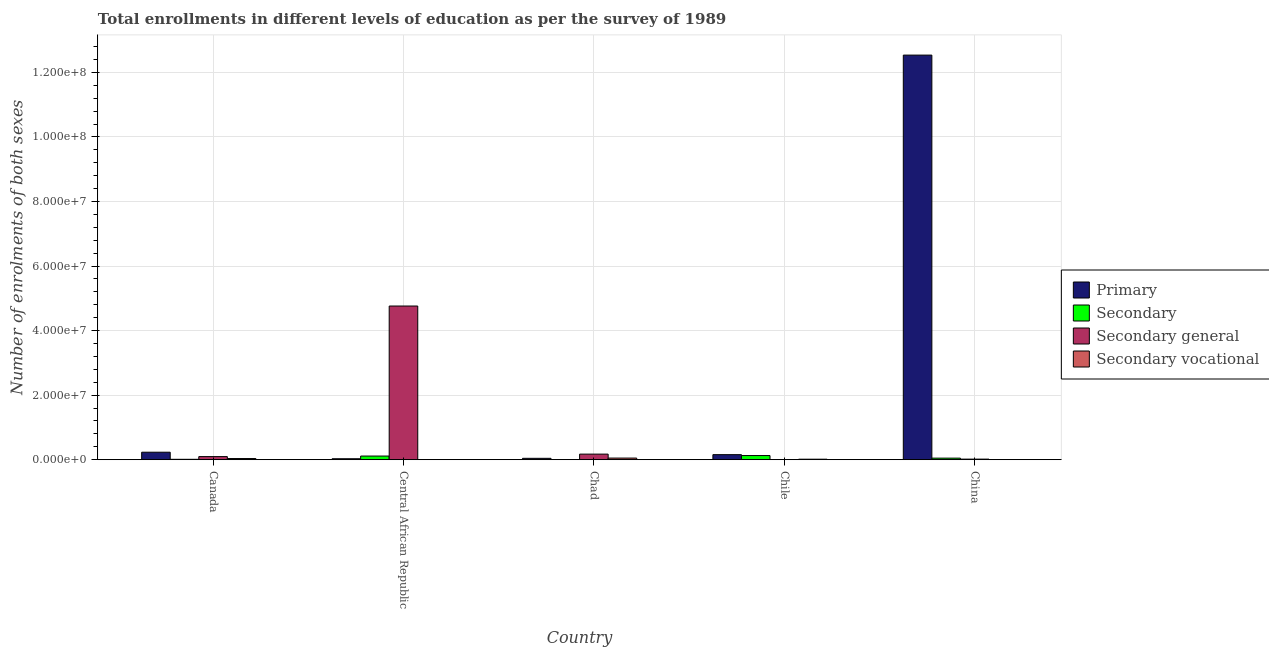How many different coloured bars are there?
Your answer should be compact. 4. Are the number of bars on each tick of the X-axis equal?
Offer a terse response. Yes. How many bars are there on the 2nd tick from the right?
Make the answer very short. 4. What is the number of enrolments in primary education in China?
Provide a short and direct response. 1.25e+08. Across all countries, what is the maximum number of enrolments in secondary general education?
Give a very brief answer. 4.76e+07. Across all countries, what is the minimum number of enrolments in secondary education?
Ensure brevity in your answer.  4.26e+04. In which country was the number of enrolments in primary education minimum?
Keep it short and to the point. Central African Republic. What is the total number of enrolments in secondary general education in the graph?
Your answer should be very brief. 5.05e+07. What is the difference between the number of enrolments in secondary education in Chad and that in Chile?
Keep it short and to the point. -1.24e+06. What is the difference between the number of enrolments in secondary education in Chad and the number of enrolments in primary education in Canada?
Your response must be concise. -2.28e+06. What is the average number of enrolments in secondary general education per country?
Give a very brief answer. 1.01e+07. What is the difference between the number of enrolments in secondary vocational education and number of enrolments in secondary general education in Chile?
Keep it short and to the point. 1.38e+05. What is the ratio of the number of enrolments in secondary vocational education in Canada to that in China?
Ensure brevity in your answer.  151.02. Is the difference between the number of enrolments in primary education in Canada and Chad greater than the difference between the number of enrolments in secondary general education in Canada and Chad?
Make the answer very short. Yes. What is the difference between the highest and the second highest number of enrolments in secondary general education?
Make the answer very short. 4.59e+07. What is the difference between the highest and the lowest number of enrolments in secondary general education?
Make the answer very short. 4.76e+07. Is the sum of the number of enrolments in secondary vocational education in Canada and China greater than the maximum number of enrolments in secondary education across all countries?
Offer a terse response. No. What does the 3rd bar from the left in Chile represents?
Your answer should be compact. Secondary general. What does the 4th bar from the right in China represents?
Your response must be concise. Primary. How many bars are there?
Provide a succinct answer. 20. Are all the bars in the graph horizontal?
Ensure brevity in your answer.  No. Does the graph contain any zero values?
Keep it short and to the point. No. Where does the legend appear in the graph?
Ensure brevity in your answer.  Center right. How are the legend labels stacked?
Offer a terse response. Vertical. What is the title of the graph?
Provide a short and direct response. Total enrollments in different levels of education as per the survey of 1989. What is the label or title of the X-axis?
Your answer should be compact. Country. What is the label or title of the Y-axis?
Your answer should be compact. Number of enrolments of both sexes. What is the Number of enrolments of both sexes of Primary in Canada?
Your response must be concise. 2.32e+06. What is the Number of enrolments of both sexes of Secondary in Canada?
Give a very brief answer. 1.23e+05. What is the Number of enrolments of both sexes in Secondary general in Canada?
Offer a terse response. 9.62e+05. What is the Number of enrolments of both sexes in Secondary vocational in Canada?
Your answer should be very brief. 3.57e+05. What is the Number of enrolments of both sexes of Primary in Central African Republic?
Provide a short and direct response. 2.97e+05. What is the Number of enrolments of both sexes in Secondary in Central African Republic?
Your answer should be compact. 1.13e+06. What is the Number of enrolments of both sexes in Secondary general in Central African Republic?
Make the answer very short. 4.76e+07. What is the Number of enrolments of both sexes of Secondary vocational in Central African Republic?
Make the answer very short. 3314. What is the Number of enrolments of both sexes in Primary in Chad?
Your answer should be compact. 4.25e+05. What is the Number of enrolments of both sexes in Secondary in Chad?
Give a very brief answer. 4.26e+04. What is the Number of enrolments of both sexes of Secondary general in Chad?
Your answer should be very brief. 1.73e+06. What is the Number of enrolments of both sexes in Secondary vocational in Chad?
Ensure brevity in your answer.  5.05e+05. What is the Number of enrolments of both sexes of Primary in Chile?
Your answer should be very brief. 1.56e+06. What is the Number of enrolments of both sexes of Secondary in Chile?
Give a very brief answer. 1.29e+06. What is the Number of enrolments of both sexes in Secondary general in Chile?
Offer a very short reply. 1.73e+04. What is the Number of enrolments of both sexes in Secondary vocational in Chile?
Ensure brevity in your answer.  1.56e+05. What is the Number of enrolments of both sexes of Primary in China?
Provide a short and direct response. 1.25e+08. What is the Number of enrolments of both sexes in Secondary in China?
Offer a very short reply. 4.84e+05. What is the Number of enrolments of both sexes in Secondary general in China?
Your answer should be very brief. 1.80e+05. What is the Number of enrolments of both sexes in Secondary vocational in China?
Make the answer very short. 2366. Across all countries, what is the maximum Number of enrolments of both sexes in Primary?
Your response must be concise. 1.25e+08. Across all countries, what is the maximum Number of enrolments of both sexes in Secondary?
Offer a very short reply. 1.29e+06. Across all countries, what is the maximum Number of enrolments of both sexes in Secondary general?
Provide a succinct answer. 4.76e+07. Across all countries, what is the maximum Number of enrolments of both sexes in Secondary vocational?
Give a very brief answer. 5.05e+05. Across all countries, what is the minimum Number of enrolments of both sexes in Primary?
Provide a short and direct response. 2.97e+05. Across all countries, what is the minimum Number of enrolments of both sexes in Secondary?
Make the answer very short. 4.26e+04. Across all countries, what is the minimum Number of enrolments of both sexes of Secondary general?
Your answer should be compact. 1.73e+04. Across all countries, what is the minimum Number of enrolments of both sexes in Secondary vocational?
Your answer should be very brief. 2366. What is the total Number of enrolments of both sexes of Primary in the graph?
Give a very brief answer. 1.30e+08. What is the total Number of enrolments of both sexes of Secondary in the graph?
Your response must be concise. 3.06e+06. What is the total Number of enrolments of both sexes of Secondary general in the graph?
Provide a short and direct response. 5.05e+07. What is the total Number of enrolments of both sexes of Secondary vocational in the graph?
Keep it short and to the point. 1.02e+06. What is the difference between the Number of enrolments of both sexes in Primary in Canada and that in Central African Republic?
Give a very brief answer. 2.02e+06. What is the difference between the Number of enrolments of both sexes in Secondary in Canada and that in Central African Republic?
Make the answer very short. -1.00e+06. What is the difference between the Number of enrolments of both sexes of Secondary general in Canada and that in Central African Republic?
Your answer should be very brief. -4.67e+07. What is the difference between the Number of enrolments of both sexes of Secondary vocational in Canada and that in Central African Republic?
Give a very brief answer. 3.54e+05. What is the difference between the Number of enrolments of both sexes of Primary in Canada and that in Chad?
Keep it short and to the point. 1.89e+06. What is the difference between the Number of enrolments of both sexes of Secondary in Canada and that in Chad?
Your response must be concise. 8.04e+04. What is the difference between the Number of enrolments of both sexes in Secondary general in Canada and that in Chad?
Your answer should be compact. -7.67e+05. What is the difference between the Number of enrolments of both sexes in Secondary vocational in Canada and that in Chad?
Offer a very short reply. -1.48e+05. What is the difference between the Number of enrolments of both sexes of Primary in Canada and that in Chile?
Your answer should be compact. 7.55e+05. What is the difference between the Number of enrolments of both sexes of Secondary in Canada and that in Chile?
Give a very brief answer. -1.16e+06. What is the difference between the Number of enrolments of both sexes of Secondary general in Canada and that in Chile?
Keep it short and to the point. 9.44e+05. What is the difference between the Number of enrolments of both sexes in Secondary vocational in Canada and that in Chile?
Ensure brevity in your answer.  2.02e+05. What is the difference between the Number of enrolments of both sexes of Primary in Canada and that in China?
Provide a succinct answer. -1.23e+08. What is the difference between the Number of enrolments of both sexes of Secondary in Canada and that in China?
Provide a short and direct response. -3.60e+05. What is the difference between the Number of enrolments of both sexes in Secondary general in Canada and that in China?
Ensure brevity in your answer.  7.82e+05. What is the difference between the Number of enrolments of both sexes of Secondary vocational in Canada and that in China?
Make the answer very short. 3.55e+05. What is the difference between the Number of enrolments of both sexes in Primary in Central African Republic and that in Chad?
Provide a succinct answer. -1.27e+05. What is the difference between the Number of enrolments of both sexes of Secondary in Central African Republic and that in Chad?
Your answer should be compact. 1.08e+06. What is the difference between the Number of enrolments of both sexes in Secondary general in Central African Republic and that in Chad?
Your response must be concise. 4.59e+07. What is the difference between the Number of enrolments of both sexes of Secondary vocational in Central African Republic and that in Chad?
Provide a short and direct response. -5.02e+05. What is the difference between the Number of enrolments of both sexes of Primary in Central African Republic and that in Chile?
Keep it short and to the point. -1.27e+06. What is the difference between the Number of enrolments of both sexes of Secondary in Central African Republic and that in Chile?
Your response must be concise. -1.59e+05. What is the difference between the Number of enrolments of both sexes of Secondary general in Central African Republic and that in Chile?
Your answer should be compact. 4.76e+07. What is the difference between the Number of enrolments of both sexes in Secondary vocational in Central African Republic and that in Chile?
Make the answer very short. -1.52e+05. What is the difference between the Number of enrolments of both sexes of Primary in Central African Republic and that in China?
Offer a very short reply. -1.25e+08. What is the difference between the Number of enrolments of both sexes in Secondary in Central African Republic and that in China?
Ensure brevity in your answer.  6.44e+05. What is the difference between the Number of enrolments of both sexes in Secondary general in Central African Republic and that in China?
Provide a succinct answer. 4.74e+07. What is the difference between the Number of enrolments of both sexes in Secondary vocational in Central African Republic and that in China?
Make the answer very short. 948. What is the difference between the Number of enrolments of both sexes in Primary in Chad and that in Chile?
Provide a succinct answer. -1.14e+06. What is the difference between the Number of enrolments of both sexes in Secondary in Chad and that in Chile?
Offer a very short reply. -1.24e+06. What is the difference between the Number of enrolments of both sexes of Secondary general in Chad and that in Chile?
Provide a short and direct response. 1.71e+06. What is the difference between the Number of enrolments of both sexes in Secondary vocational in Chad and that in Chile?
Make the answer very short. 3.50e+05. What is the difference between the Number of enrolments of both sexes of Primary in Chad and that in China?
Ensure brevity in your answer.  -1.25e+08. What is the difference between the Number of enrolments of both sexes in Secondary in Chad and that in China?
Your response must be concise. -4.41e+05. What is the difference between the Number of enrolments of both sexes in Secondary general in Chad and that in China?
Offer a terse response. 1.55e+06. What is the difference between the Number of enrolments of both sexes of Secondary vocational in Chad and that in China?
Your response must be concise. 5.03e+05. What is the difference between the Number of enrolments of both sexes in Primary in Chile and that in China?
Your answer should be compact. -1.24e+08. What is the difference between the Number of enrolments of both sexes in Secondary in Chile and that in China?
Offer a very short reply. 8.02e+05. What is the difference between the Number of enrolments of both sexes of Secondary general in Chile and that in China?
Provide a succinct answer. -1.63e+05. What is the difference between the Number of enrolments of both sexes in Secondary vocational in Chile and that in China?
Offer a very short reply. 1.53e+05. What is the difference between the Number of enrolments of both sexes in Primary in Canada and the Number of enrolments of both sexes in Secondary in Central African Republic?
Offer a very short reply. 1.19e+06. What is the difference between the Number of enrolments of both sexes of Primary in Canada and the Number of enrolments of both sexes of Secondary general in Central African Republic?
Make the answer very short. -4.53e+07. What is the difference between the Number of enrolments of both sexes in Primary in Canada and the Number of enrolments of both sexes in Secondary vocational in Central African Republic?
Keep it short and to the point. 2.32e+06. What is the difference between the Number of enrolments of both sexes in Secondary in Canada and the Number of enrolments of both sexes in Secondary general in Central African Republic?
Your answer should be compact. -4.75e+07. What is the difference between the Number of enrolments of both sexes of Secondary in Canada and the Number of enrolments of both sexes of Secondary vocational in Central African Republic?
Your answer should be very brief. 1.20e+05. What is the difference between the Number of enrolments of both sexes of Secondary general in Canada and the Number of enrolments of both sexes of Secondary vocational in Central African Republic?
Offer a very short reply. 9.58e+05. What is the difference between the Number of enrolments of both sexes in Primary in Canada and the Number of enrolments of both sexes in Secondary in Chad?
Provide a succinct answer. 2.28e+06. What is the difference between the Number of enrolments of both sexes in Primary in Canada and the Number of enrolments of both sexes in Secondary general in Chad?
Provide a succinct answer. 5.90e+05. What is the difference between the Number of enrolments of both sexes of Primary in Canada and the Number of enrolments of both sexes of Secondary vocational in Chad?
Offer a terse response. 1.81e+06. What is the difference between the Number of enrolments of both sexes of Secondary in Canada and the Number of enrolments of both sexes of Secondary general in Chad?
Keep it short and to the point. -1.61e+06. What is the difference between the Number of enrolments of both sexes of Secondary in Canada and the Number of enrolments of both sexes of Secondary vocational in Chad?
Your response must be concise. -3.82e+05. What is the difference between the Number of enrolments of both sexes in Secondary general in Canada and the Number of enrolments of both sexes in Secondary vocational in Chad?
Offer a very short reply. 4.56e+05. What is the difference between the Number of enrolments of both sexes of Primary in Canada and the Number of enrolments of both sexes of Secondary in Chile?
Your response must be concise. 1.03e+06. What is the difference between the Number of enrolments of both sexes in Primary in Canada and the Number of enrolments of both sexes in Secondary general in Chile?
Make the answer very short. 2.30e+06. What is the difference between the Number of enrolments of both sexes of Primary in Canada and the Number of enrolments of both sexes of Secondary vocational in Chile?
Your answer should be compact. 2.16e+06. What is the difference between the Number of enrolments of both sexes of Secondary in Canada and the Number of enrolments of both sexes of Secondary general in Chile?
Provide a short and direct response. 1.06e+05. What is the difference between the Number of enrolments of both sexes of Secondary in Canada and the Number of enrolments of both sexes of Secondary vocational in Chile?
Provide a short and direct response. -3.27e+04. What is the difference between the Number of enrolments of both sexes of Secondary general in Canada and the Number of enrolments of both sexes of Secondary vocational in Chile?
Provide a succinct answer. 8.06e+05. What is the difference between the Number of enrolments of both sexes in Primary in Canada and the Number of enrolments of both sexes in Secondary in China?
Ensure brevity in your answer.  1.84e+06. What is the difference between the Number of enrolments of both sexes of Primary in Canada and the Number of enrolments of both sexes of Secondary general in China?
Offer a very short reply. 2.14e+06. What is the difference between the Number of enrolments of both sexes of Primary in Canada and the Number of enrolments of both sexes of Secondary vocational in China?
Make the answer very short. 2.32e+06. What is the difference between the Number of enrolments of both sexes in Secondary in Canada and the Number of enrolments of both sexes in Secondary general in China?
Offer a terse response. -5.68e+04. What is the difference between the Number of enrolments of both sexes of Secondary in Canada and the Number of enrolments of both sexes of Secondary vocational in China?
Your answer should be very brief. 1.21e+05. What is the difference between the Number of enrolments of both sexes in Secondary general in Canada and the Number of enrolments of both sexes in Secondary vocational in China?
Give a very brief answer. 9.59e+05. What is the difference between the Number of enrolments of both sexes of Primary in Central African Republic and the Number of enrolments of both sexes of Secondary in Chad?
Your answer should be very brief. 2.55e+05. What is the difference between the Number of enrolments of both sexes in Primary in Central African Republic and the Number of enrolments of both sexes in Secondary general in Chad?
Offer a very short reply. -1.43e+06. What is the difference between the Number of enrolments of both sexes of Primary in Central African Republic and the Number of enrolments of both sexes of Secondary vocational in Chad?
Provide a succinct answer. -2.08e+05. What is the difference between the Number of enrolments of both sexes of Secondary in Central African Republic and the Number of enrolments of both sexes of Secondary general in Chad?
Make the answer very short. -6.02e+05. What is the difference between the Number of enrolments of both sexes in Secondary in Central African Republic and the Number of enrolments of both sexes in Secondary vocational in Chad?
Offer a terse response. 6.22e+05. What is the difference between the Number of enrolments of both sexes in Secondary general in Central African Republic and the Number of enrolments of both sexes in Secondary vocational in Chad?
Keep it short and to the point. 4.71e+07. What is the difference between the Number of enrolments of both sexes of Primary in Central African Republic and the Number of enrolments of both sexes of Secondary in Chile?
Make the answer very short. -9.88e+05. What is the difference between the Number of enrolments of both sexes of Primary in Central African Republic and the Number of enrolments of both sexes of Secondary general in Chile?
Offer a terse response. 2.80e+05. What is the difference between the Number of enrolments of both sexes in Primary in Central African Republic and the Number of enrolments of both sexes in Secondary vocational in Chile?
Your response must be concise. 1.42e+05. What is the difference between the Number of enrolments of both sexes of Secondary in Central African Republic and the Number of enrolments of both sexes of Secondary general in Chile?
Make the answer very short. 1.11e+06. What is the difference between the Number of enrolments of both sexes of Secondary in Central African Republic and the Number of enrolments of both sexes of Secondary vocational in Chile?
Your answer should be very brief. 9.71e+05. What is the difference between the Number of enrolments of both sexes in Secondary general in Central African Republic and the Number of enrolments of both sexes in Secondary vocational in Chile?
Offer a terse response. 4.75e+07. What is the difference between the Number of enrolments of both sexes of Primary in Central African Republic and the Number of enrolments of both sexes of Secondary in China?
Offer a terse response. -1.86e+05. What is the difference between the Number of enrolments of both sexes of Primary in Central African Republic and the Number of enrolments of both sexes of Secondary general in China?
Offer a terse response. 1.18e+05. What is the difference between the Number of enrolments of both sexes in Primary in Central African Republic and the Number of enrolments of both sexes in Secondary vocational in China?
Provide a succinct answer. 2.95e+05. What is the difference between the Number of enrolments of both sexes in Secondary in Central African Republic and the Number of enrolments of both sexes in Secondary general in China?
Offer a very short reply. 9.47e+05. What is the difference between the Number of enrolments of both sexes of Secondary in Central African Republic and the Number of enrolments of both sexes of Secondary vocational in China?
Ensure brevity in your answer.  1.12e+06. What is the difference between the Number of enrolments of both sexes of Secondary general in Central African Republic and the Number of enrolments of both sexes of Secondary vocational in China?
Your response must be concise. 4.76e+07. What is the difference between the Number of enrolments of both sexes of Primary in Chad and the Number of enrolments of both sexes of Secondary in Chile?
Provide a short and direct response. -8.61e+05. What is the difference between the Number of enrolments of both sexes of Primary in Chad and the Number of enrolments of both sexes of Secondary general in Chile?
Make the answer very short. 4.08e+05. What is the difference between the Number of enrolments of both sexes of Primary in Chad and the Number of enrolments of both sexes of Secondary vocational in Chile?
Keep it short and to the point. 2.69e+05. What is the difference between the Number of enrolments of both sexes in Secondary in Chad and the Number of enrolments of both sexes in Secondary general in Chile?
Give a very brief answer. 2.53e+04. What is the difference between the Number of enrolments of both sexes in Secondary in Chad and the Number of enrolments of both sexes in Secondary vocational in Chile?
Ensure brevity in your answer.  -1.13e+05. What is the difference between the Number of enrolments of both sexes in Secondary general in Chad and the Number of enrolments of both sexes in Secondary vocational in Chile?
Keep it short and to the point. 1.57e+06. What is the difference between the Number of enrolments of both sexes in Primary in Chad and the Number of enrolments of both sexes in Secondary in China?
Provide a succinct answer. -5.86e+04. What is the difference between the Number of enrolments of both sexes of Primary in Chad and the Number of enrolments of both sexes of Secondary general in China?
Offer a terse response. 2.45e+05. What is the difference between the Number of enrolments of both sexes in Primary in Chad and the Number of enrolments of both sexes in Secondary vocational in China?
Ensure brevity in your answer.  4.23e+05. What is the difference between the Number of enrolments of both sexes of Secondary in Chad and the Number of enrolments of both sexes of Secondary general in China?
Keep it short and to the point. -1.37e+05. What is the difference between the Number of enrolments of both sexes of Secondary in Chad and the Number of enrolments of both sexes of Secondary vocational in China?
Your answer should be very brief. 4.02e+04. What is the difference between the Number of enrolments of both sexes in Secondary general in Chad and the Number of enrolments of both sexes in Secondary vocational in China?
Provide a succinct answer. 1.73e+06. What is the difference between the Number of enrolments of both sexes of Primary in Chile and the Number of enrolments of both sexes of Secondary in China?
Make the answer very short. 1.08e+06. What is the difference between the Number of enrolments of both sexes in Primary in Chile and the Number of enrolments of both sexes in Secondary general in China?
Give a very brief answer. 1.38e+06. What is the difference between the Number of enrolments of both sexes of Primary in Chile and the Number of enrolments of both sexes of Secondary vocational in China?
Offer a very short reply. 1.56e+06. What is the difference between the Number of enrolments of both sexes in Secondary in Chile and the Number of enrolments of both sexes in Secondary general in China?
Offer a terse response. 1.11e+06. What is the difference between the Number of enrolments of both sexes in Secondary in Chile and the Number of enrolments of both sexes in Secondary vocational in China?
Provide a short and direct response. 1.28e+06. What is the difference between the Number of enrolments of both sexes in Secondary general in Chile and the Number of enrolments of both sexes in Secondary vocational in China?
Make the answer very short. 1.49e+04. What is the average Number of enrolments of both sexes in Primary per country?
Provide a succinct answer. 2.60e+07. What is the average Number of enrolments of both sexes in Secondary per country?
Your answer should be compact. 6.12e+05. What is the average Number of enrolments of both sexes in Secondary general per country?
Provide a succinct answer. 1.01e+07. What is the average Number of enrolments of both sexes of Secondary vocational per country?
Offer a very short reply. 2.05e+05. What is the difference between the Number of enrolments of both sexes in Primary and Number of enrolments of both sexes in Secondary in Canada?
Your answer should be compact. 2.20e+06. What is the difference between the Number of enrolments of both sexes of Primary and Number of enrolments of both sexes of Secondary general in Canada?
Give a very brief answer. 1.36e+06. What is the difference between the Number of enrolments of both sexes in Primary and Number of enrolments of both sexes in Secondary vocational in Canada?
Provide a short and direct response. 1.96e+06. What is the difference between the Number of enrolments of both sexes of Secondary and Number of enrolments of both sexes of Secondary general in Canada?
Offer a terse response. -8.39e+05. What is the difference between the Number of enrolments of both sexes of Secondary and Number of enrolments of both sexes of Secondary vocational in Canada?
Provide a succinct answer. -2.34e+05. What is the difference between the Number of enrolments of both sexes of Secondary general and Number of enrolments of both sexes of Secondary vocational in Canada?
Offer a terse response. 6.04e+05. What is the difference between the Number of enrolments of both sexes of Primary and Number of enrolments of both sexes of Secondary in Central African Republic?
Make the answer very short. -8.30e+05. What is the difference between the Number of enrolments of both sexes in Primary and Number of enrolments of both sexes in Secondary general in Central African Republic?
Provide a short and direct response. -4.73e+07. What is the difference between the Number of enrolments of both sexes in Primary and Number of enrolments of both sexes in Secondary vocational in Central African Republic?
Your answer should be compact. 2.94e+05. What is the difference between the Number of enrolments of both sexes of Secondary and Number of enrolments of both sexes of Secondary general in Central African Republic?
Keep it short and to the point. -4.65e+07. What is the difference between the Number of enrolments of both sexes of Secondary and Number of enrolments of both sexes of Secondary vocational in Central African Republic?
Make the answer very short. 1.12e+06. What is the difference between the Number of enrolments of both sexes in Secondary general and Number of enrolments of both sexes in Secondary vocational in Central African Republic?
Offer a terse response. 4.76e+07. What is the difference between the Number of enrolments of both sexes of Primary and Number of enrolments of both sexes of Secondary in Chad?
Your answer should be compact. 3.82e+05. What is the difference between the Number of enrolments of both sexes in Primary and Number of enrolments of both sexes in Secondary general in Chad?
Your response must be concise. -1.30e+06. What is the difference between the Number of enrolments of both sexes in Primary and Number of enrolments of both sexes in Secondary vocational in Chad?
Your answer should be very brief. -8.05e+04. What is the difference between the Number of enrolments of both sexes of Secondary and Number of enrolments of both sexes of Secondary general in Chad?
Your answer should be compact. -1.69e+06. What is the difference between the Number of enrolments of both sexes of Secondary and Number of enrolments of both sexes of Secondary vocational in Chad?
Keep it short and to the point. -4.63e+05. What is the difference between the Number of enrolments of both sexes in Secondary general and Number of enrolments of both sexes in Secondary vocational in Chad?
Ensure brevity in your answer.  1.22e+06. What is the difference between the Number of enrolments of both sexes of Primary and Number of enrolments of both sexes of Secondary in Chile?
Your answer should be compact. 2.78e+05. What is the difference between the Number of enrolments of both sexes in Primary and Number of enrolments of both sexes in Secondary general in Chile?
Ensure brevity in your answer.  1.55e+06. What is the difference between the Number of enrolments of both sexes of Primary and Number of enrolments of both sexes of Secondary vocational in Chile?
Give a very brief answer. 1.41e+06. What is the difference between the Number of enrolments of both sexes in Secondary and Number of enrolments of both sexes in Secondary general in Chile?
Give a very brief answer. 1.27e+06. What is the difference between the Number of enrolments of both sexes of Secondary and Number of enrolments of both sexes of Secondary vocational in Chile?
Provide a short and direct response. 1.13e+06. What is the difference between the Number of enrolments of both sexes of Secondary general and Number of enrolments of both sexes of Secondary vocational in Chile?
Your answer should be compact. -1.38e+05. What is the difference between the Number of enrolments of both sexes of Primary and Number of enrolments of both sexes of Secondary in China?
Your answer should be compact. 1.25e+08. What is the difference between the Number of enrolments of both sexes in Primary and Number of enrolments of both sexes in Secondary general in China?
Offer a very short reply. 1.25e+08. What is the difference between the Number of enrolments of both sexes in Primary and Number of enrolments of both sexes in Secondary vocational in China?
Provide a succinct answer. 1.25e+08. What is the difference between the Number of enrolments of both sexes in Secondary and Number of enrolments of both sexes in Secondary general in China?
Ensure brevity in your answer.  3.04e+05. What is the difference between the Number of enrolments of both sexes in Secondary and Number of enrolments of both sexes in Secondary vocational in China?
Give a very brief answer. 4.81e+05. What is the difference between the Number of enrolments of both sexes of Secondary general and Number of enrolments of both sexes of Secondary vocational in China?
Keep it short and to the point. 1.77e+05. What is the ratio of the Number of enrolments of both sexes of Primary in Canada to that in Central African Republic?
Provide a short and direct response. 7.8. What is the ratio of the Number of enrolments of both sexes of Secondary in Canada to that in Central African Republic?
Your answer should be compact. 0.11. What is the ratio of the Number of enrolments of both sexes of Secondary general in Canada to that in Central African Republic?
Make the answer very short. 0.02. What is the ratio of the Number of enrolments of both sexes of Secondary vocational in Canada to that in Central African Republic?
Offer a very short reply. 107.82. What is the ratio of the Number of enrolments of both sexes of Primary in Canada to that in Chad?
Ensure brevity in your answer.  5.46. What is the ratio of the Number of enrolments of both sexes of Secondary in Canada to that in Chad?
Ensure brevity in your answer.  2.89. What is the ratio of the Number of enrolments of both sexes in Secondary general in Canada to that in Chad?
Provide a succinct answer. 0.56. What is the ratio of the Number of enrolments of both sexes in Secondary vocational in Canada to that in Chad?
Provide a succinct answer. 0.71. What is the ratio of the Number of enrolments of both sexes in Primary in Canada to that in Chile?
Make the answer very short. 1.48. What is the ratio of the Number of enrolments of both sexes of Secondary in Canada to that in Chile?
Offer a very short reply. 0.1. What is the ratio of the Number of enrolments of both sexes of Secondary general in Canada to that in Chile?
Your response must be concise. 55.61. What is the ratio of the Number of enrolments of both sexes in Secondary vocational in Canada to that in Chile?
Offer a very short reply. 2.29. What is the ratio of the Number of enrolments of both sexes of Primary in Canada to that in China?
Make the answer very short. 0.02. What is the ratio of the Number of enrolments of both sexes of Secondary in Canada to that in China?
Ensure brevity in your answer.  0.25. What is the ratio of the Number of enrolments of both sexes of Secondary general in Canada to that in China?
Give a very brief answer. 5.35. What is the ratio of the Number of enrolments of both sexes of Secondary vocational in Canada to that in China?
Your answer should be compact. 151.02. What is the ratio of the Number of enrolments of both sexes in Primary in Central African Republic to that in Chad?
Give a very brief answer. 0.7. What is the ratio of the Number of enrolments of both sexes of Secondary in Central African Republic to that in Chad?
Your response must be concise. 26.45. What is the ratio of the Number of enrolments of both sexes in Secondary general in Central African Republic to that in Chad?
Your response must be concise. 27.54. What is the ratio of the Number of enrolments of both sexes in Secondary vocational in Central African Republic to that in Chad?
Offer a terse response. 0.01. What is the ratio of the Number of enrolments of both sexes of Primary in Central African Republic to that in Chile?
Ensure brevity in your answer.  0.19. What is the ratio of the Number of enrolments of both sexes in Secondary in Central African Republic to that in Chile?
Keep it short and to the point. 0.88. What is the ratio of the Number of enrolments of both sexes of Secondary general in Central African Republic to that in Chile?
Offer a terse response. 2753.12. What is the ratio of the Number of enrolments of both sexes in Secondary vocational in Central African Republic to that in Chile?
Offer a very short reply. 0.02. What is the ratio of the Number of enrolments of both sexes of Primary in Central African Republic to that in China?
Keep it short and to the point. 0. What is the ratio of the Number of enrolments of both sexes in Secondary in Central African Republic to that in China?
Your answer should be very brief. 2.33. What is the ratio of the Number of enrolments of both sexes in Secondary general in Central African Republic to that in China?
Make the answer very short. 264.76. What is the ratio of the Number of enrolments of both sexes of Secondary vocational in Central African Republic to that in China?
Keep it short and to the point. 1.4. What is the ratio of the Number of enrolments of both sexes in Primary in Chad to that in Chile?
Offer a very short reply. 0.27. What is the ratio of the Number of enrolments of both sexes of Secondary in Chad to that in Chile?
Give a very brief answer. 0.03. What is the ratio of the Number of enrolments of both sexes of Secondary general in Chad to that in Chile?
Keep it short and to the point. 99.98. What is the ratio of the Number of enrolments of both sexes of Secondary vocational in Chad to that in Chile?
Provide a short and direct response. 3.24. What is the ratio of the Number of enrolments of both sexes in Primary in Chad to that in China?
Ensure brevity in your answer.  0. What is the ratio of the Number of enrolments of both sexes of Secondary in Chad to that in China?
Give a very brief answer. 0.09. What is the ratio of the Number of enrolments of both sexes in Secondary general in Chad to that in China?
Keep it short and to the point. 9.61. What is the ratio of the Number of enrolments of both sexes in Secondary vocational in Chad to that in China?
Your answer should be compact. 213.63. What is the ratio of the Number of enrolments of both sexes in Primary in Chile to that in China?
Keep it short and to the point. 0.01. What is the ratio of the Number of enrolments of both sexes in Secondary in Chile to that in China?
Keep it short and to the point. 2.66. What is the ratio of the Number of enrolments of both sexes of Secondary general in Chile to that in China?
Offer a very short reply. 0.1. What is the ratio of the Number of enrolments of both sexes of Secondary vocational in Chile to that in China?
Provide a succinct answer. 65.84. What is the difference between the highest and the second highest Number of enrolments of both sexes of Primary?
Offer a very short reply. 1.23e+08. What is the difference between the highest and the second highest Number of enrolments of both sexes of Secondary?
Your answer should be compact. 1.59e+05. What is the difference between the highest and the second highest Number of enrolments of both sexes of Secondary general?
Make the answer very short. 4.59e+07. What is the difference between the highest and the second highest Number of enrolments of both sexes of Secondary vocational?
Provide a succinct answer. 1.48e+05. What is the difference between the highest and the lowest Number of enrolments of both sexes of Primary?
Make the answer very short. 1.25e+08. What is the difference between the highest and the lowest Number of enrolments of both sexes of Secondary?
Keep it short and to the point. 1.24e+06. What is the difference between the highest and the lowest Number of enrolments of both sexes of Secondary general?
Ensure brevity in your answer.  4.76e+07. What is the difference between the highest and the lowest Number of enrolments of both sexes in Secondary vocational?
Offer a very short reply. 5.03e+05. 